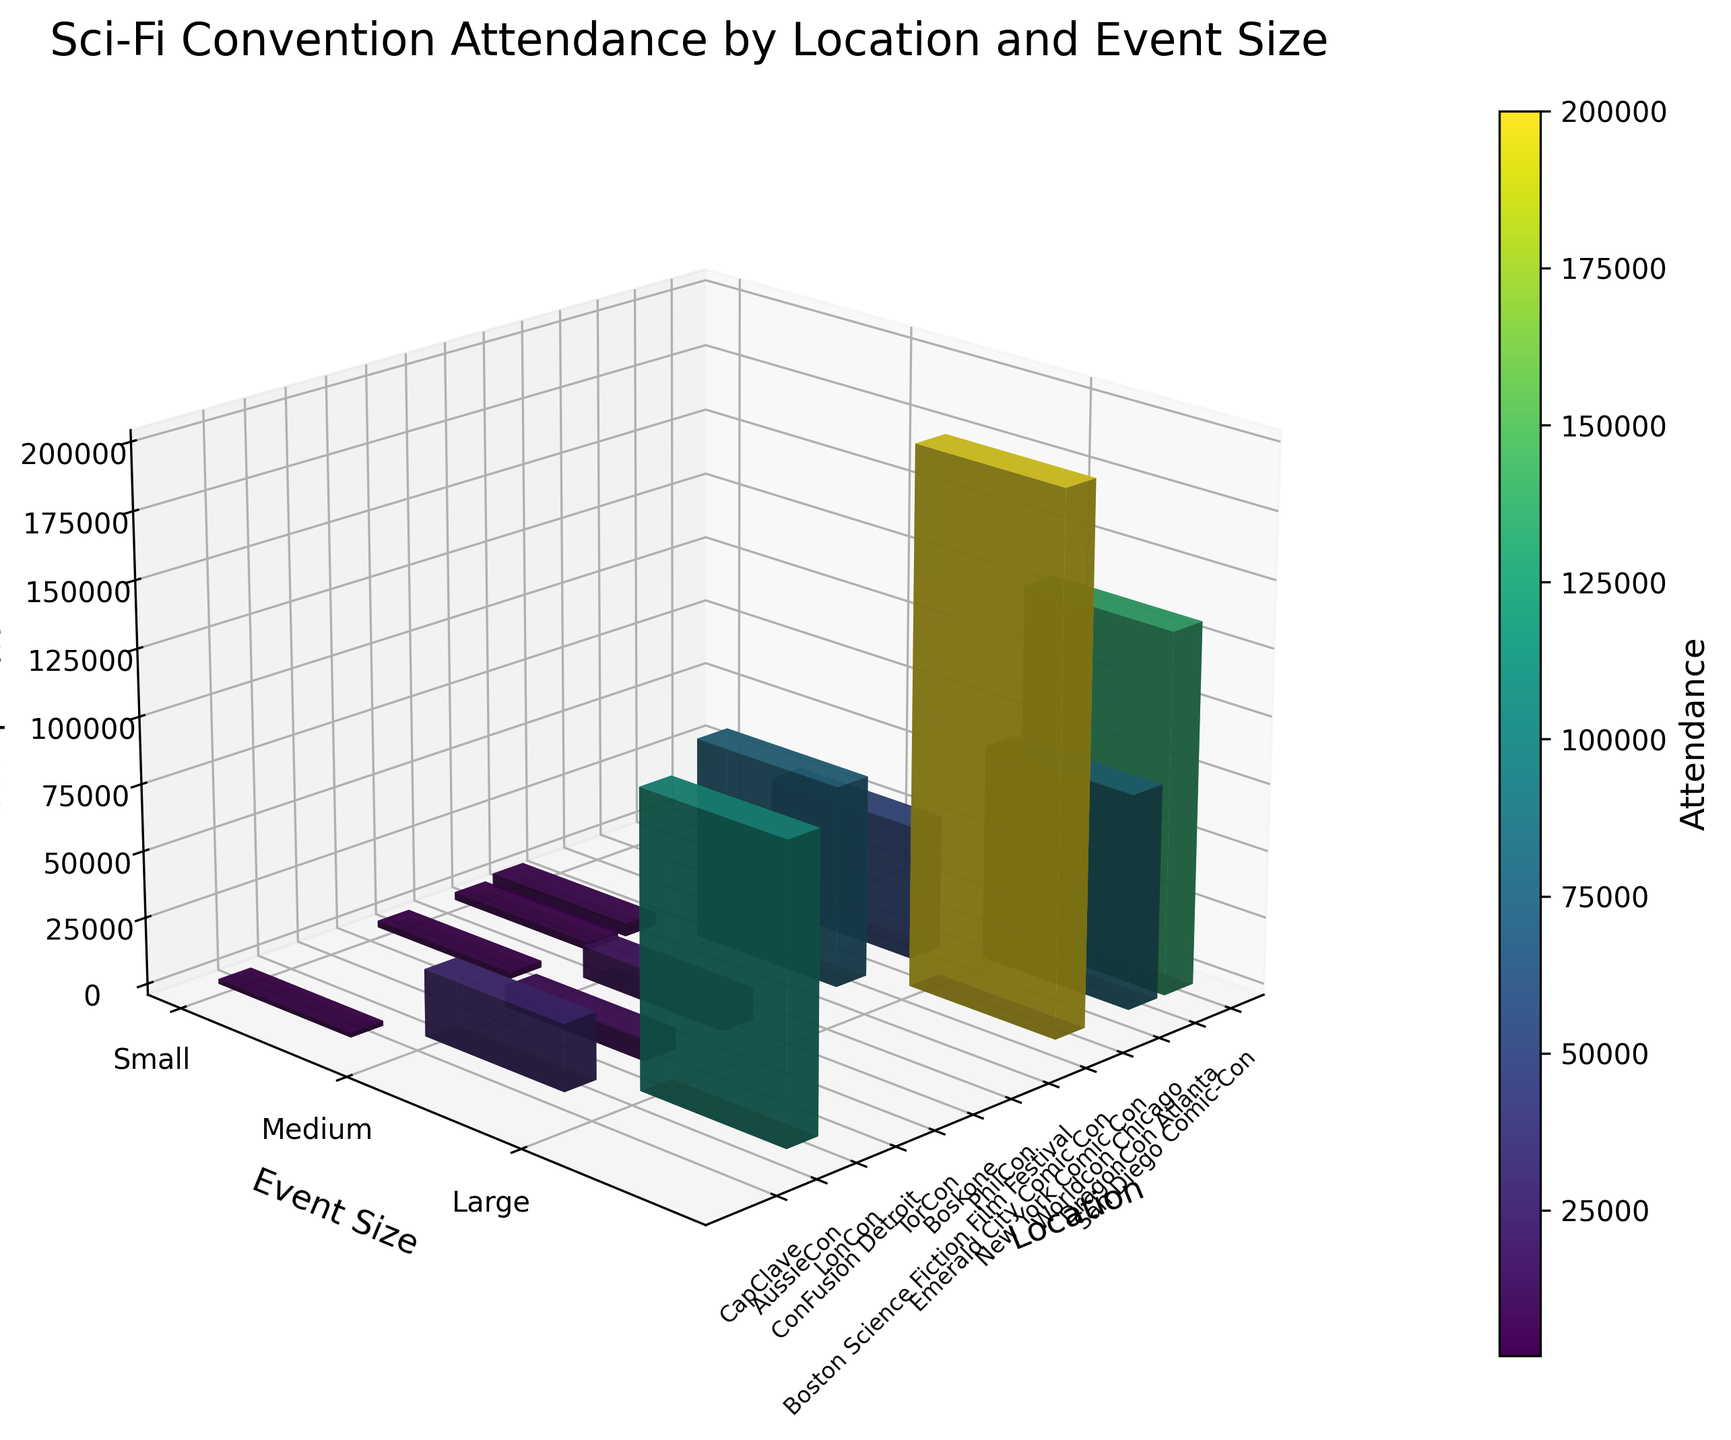What's the title of the plot? The title can be directly read from the top of the figure, which states the focus of the plot.
Answer: Sci-Fi Convention Attendance by Location and Event Size What do the colors in the 3D bars represent? The colors in the 3D bars correspond to attendance values, with the color range indicating different levels of attendance based on the color map.
Answer: Attendance Which event has the highest attendance? By looking at the tallest bar and identifying its corresponding label, we see the event with the highest attendance.
Answer: New York Comic Con What is the attendance of the event held at LonCon? Find the bar corresponding to LonCon location and note the height value based on the z-axis label.
Answer: 110,000 Which event size category has the most entries? Count the number of bars in each event size category by checking the y-axis labels and the corresponding bars.
Answer: Large Compare the attendances of San Diego Comic-Con and DragonCon Atlanta. Which one is higher and by how much? Identify the bars corresponding to these two locations, check their heights and compute the difference.
Answer: New York Comic Con is higher by 55,000 How many small-size events are included in the plot? Count the number of bars in the 'Small' category indicated by the y-axis label and corresponding bars.
Answer: 4 Which guest author is associated with the largest event size and the highest attendance? Find the bar with the largest height within the 'Large' category and identify the guest author associated with it.
Answer: Andy Weir What is the difference in attendance between the largest event and the smallest event? Find the tallest and shortest bars, note their values, and calculate the difference.
Answer: 197,000 Among medium-sized events, which one has the lowest attendance? Identify the bars within the 'Medium' category, compare their heights, and find the lowest one.
Answer: CapClave 